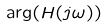<formula> <loc_0><loc_0><loc_500><loc_500>\arg ( H ( j \omega ) )</formula> 